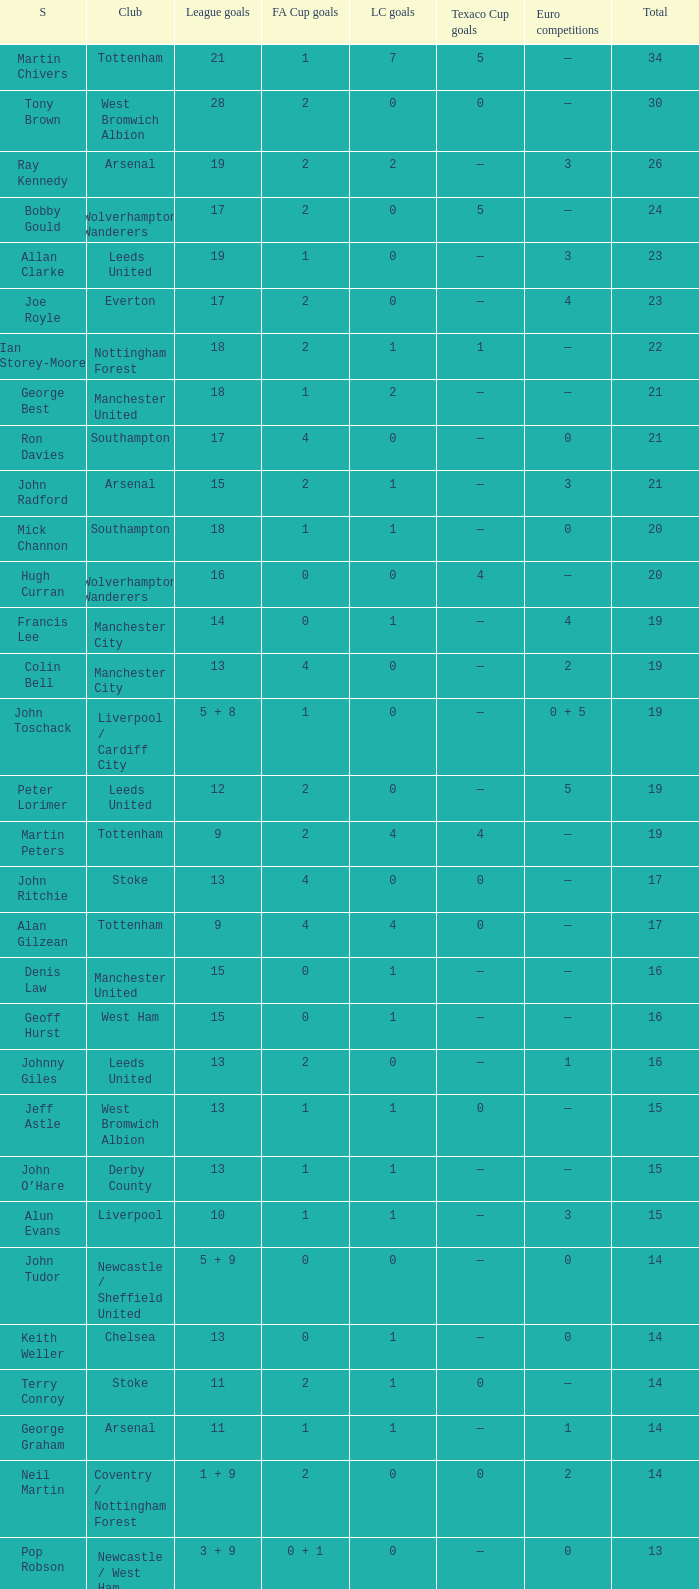What is the lowest League Cup Goals, when Scorer is Denis Law? 1.0. 